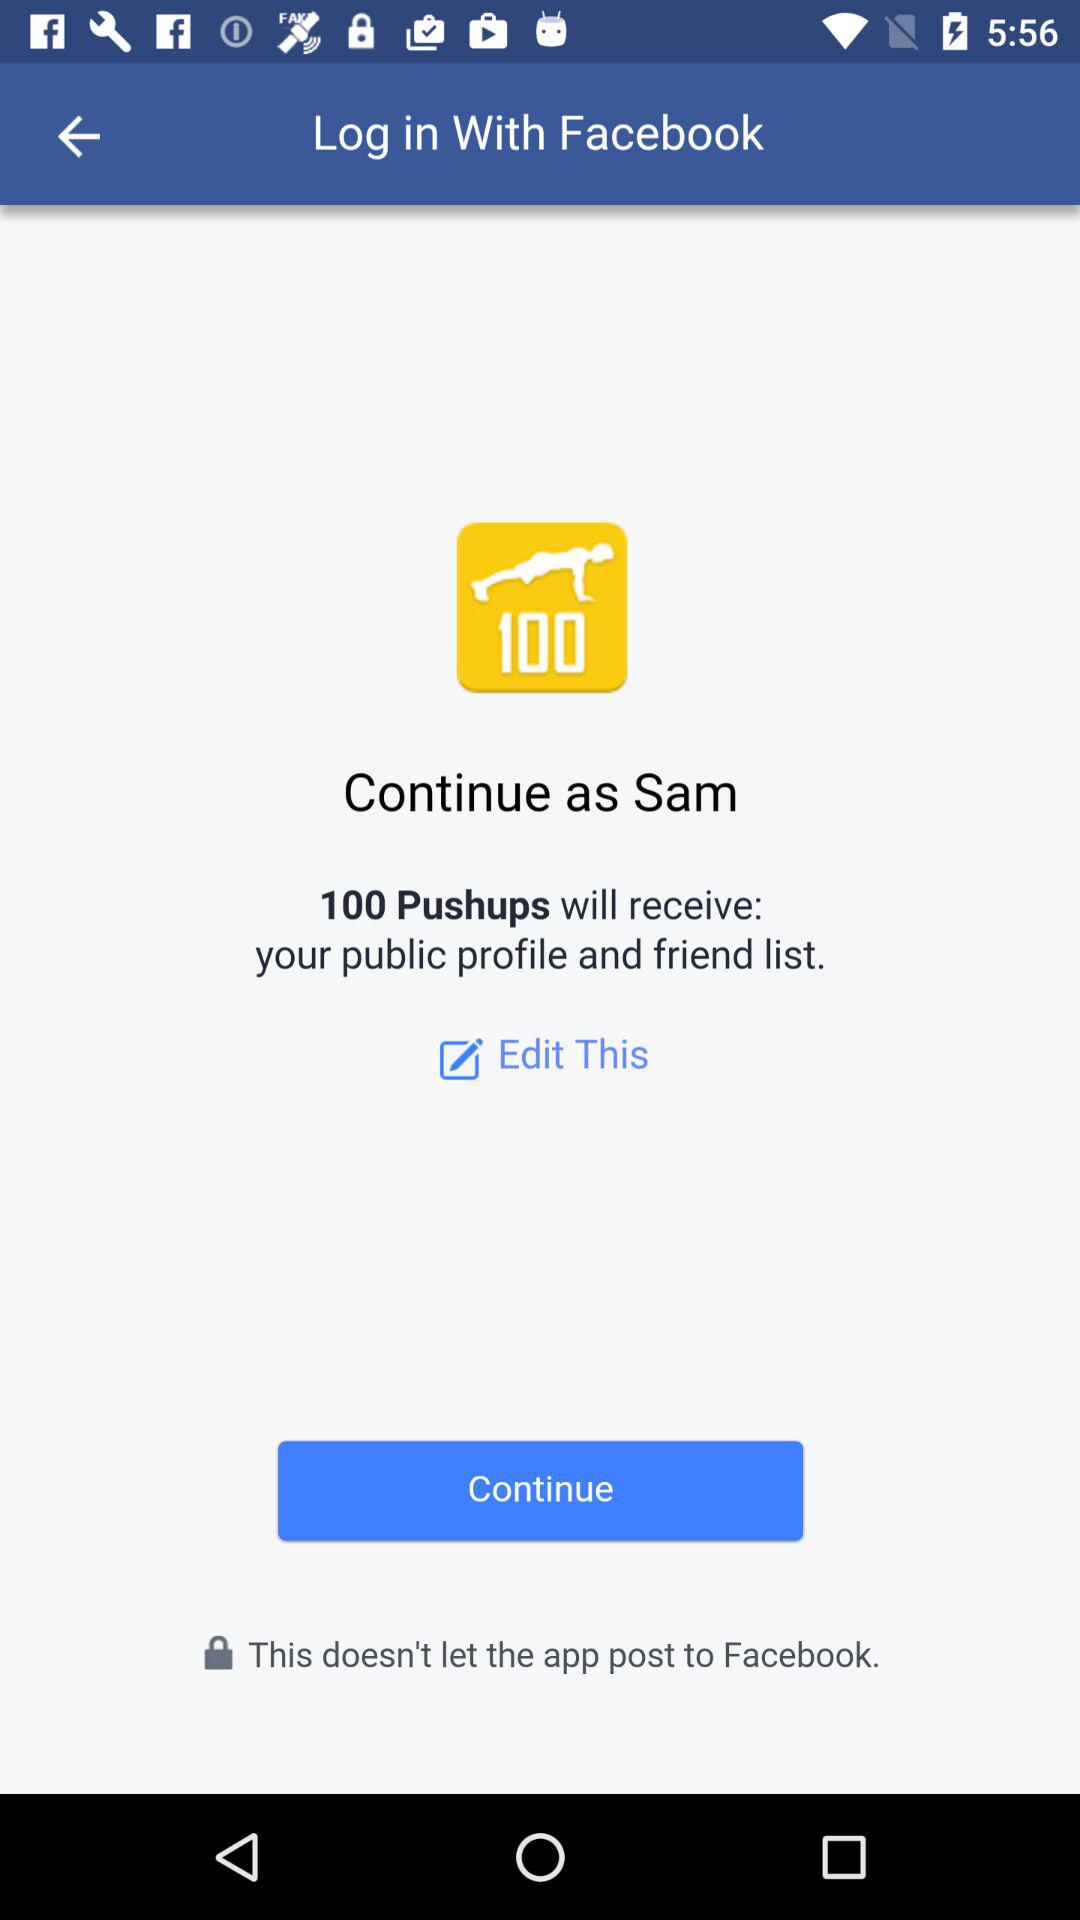Who will receive the public profile and friend list? The public profile and friend list will be received by "100 Pushups". 